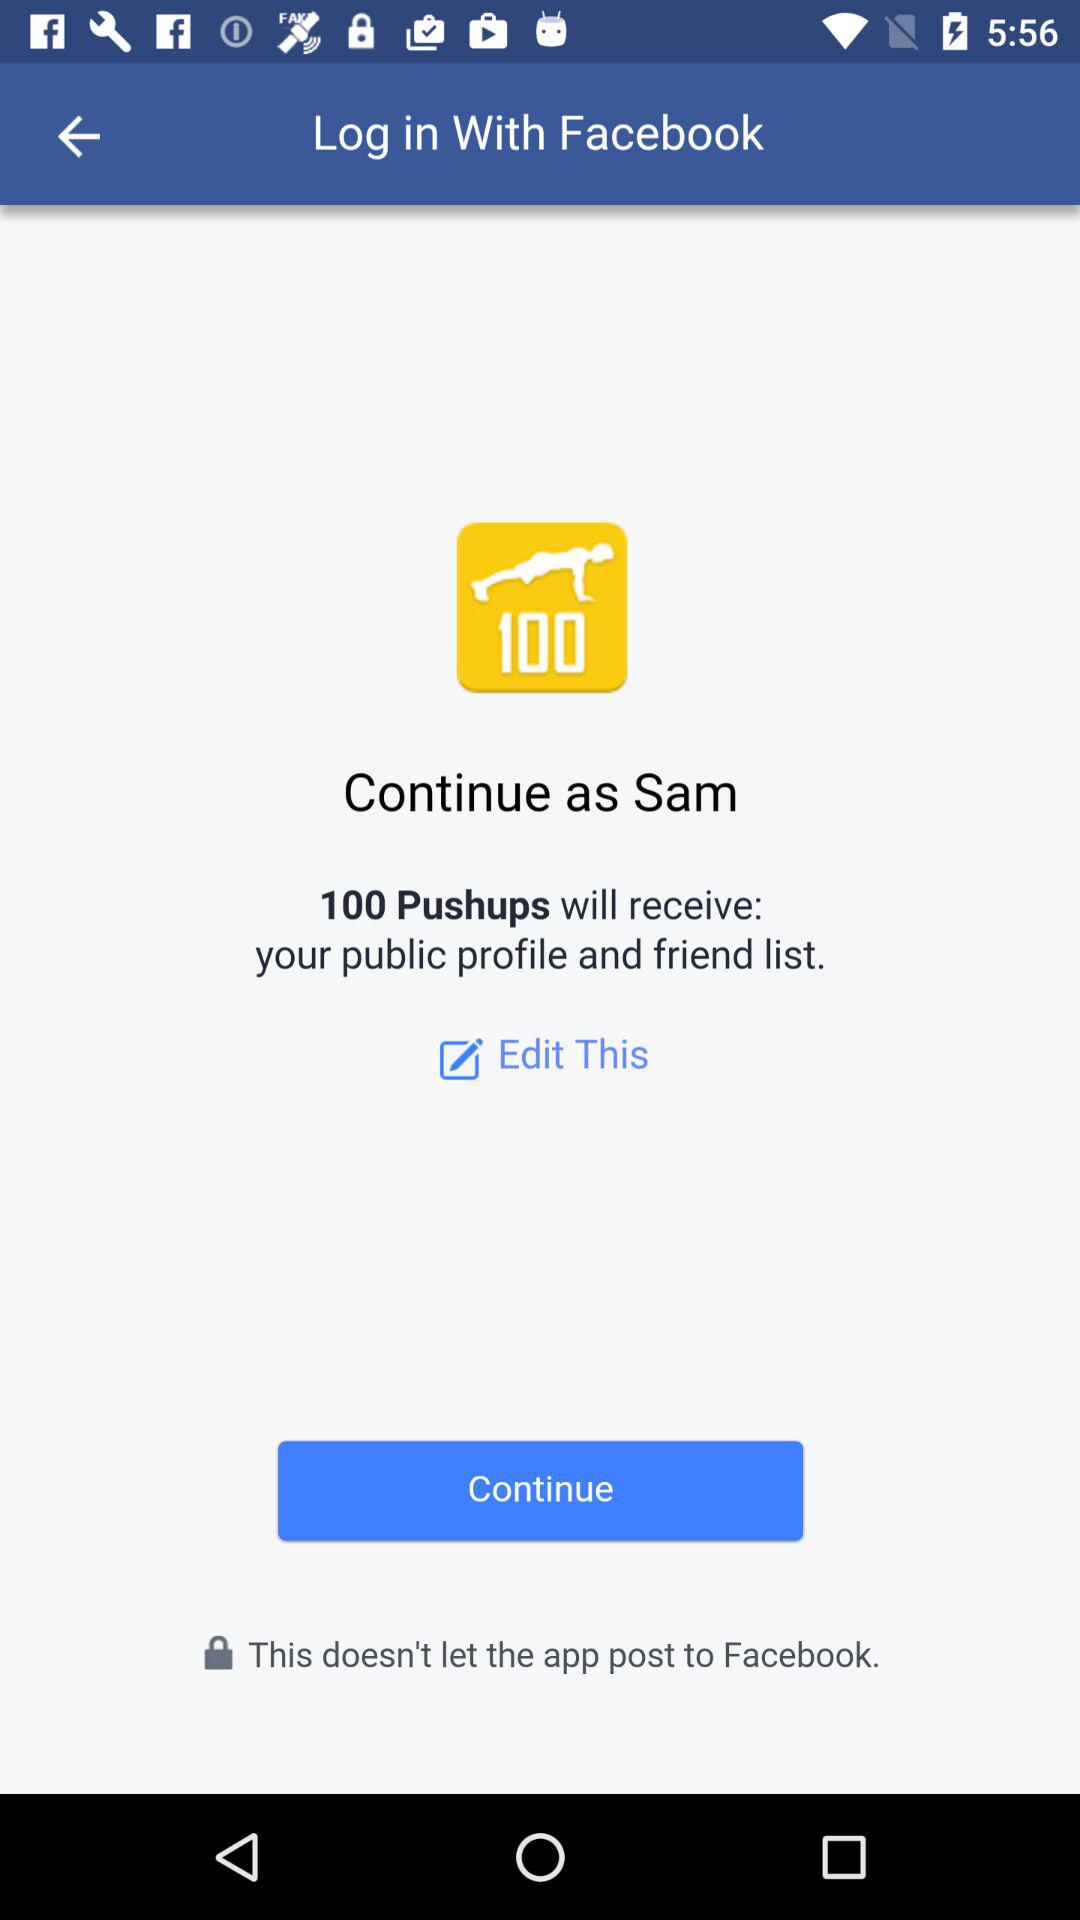Who will receive the public profile and friend list? The public profile and friend list will be received by "100 Pushups". 